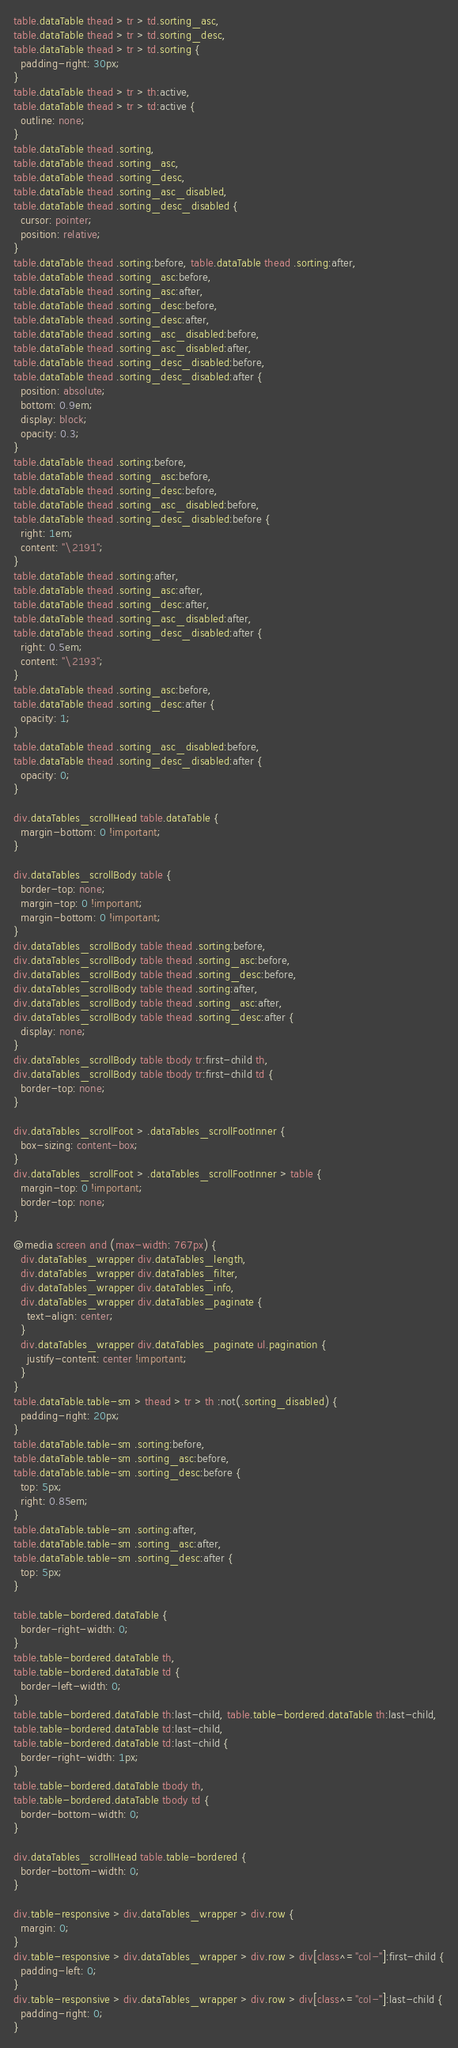Convert code to text. <code><loc_0><loc_0><loc_500><loc_500><_CSS_>table.dataTable thead > tr > td.sorting_asc,
table.dataTable thead > tr > td.sorting_desc,
table.dataTable thead > tr > td.sorting {
  padding-right: 30px;
}
table.dataTable thead > tr > th:active,
table.dataTable thead > tr > td:active {
  outline: none;
}
table.dataTable thead .sorting,
table.dataTable thead .sorting_asc,
table.dataTable thead .sorting_desc,
table.dataTable thead .sorting_asc_disabled,
table.dataTable thead .sorting_desc_disabled {
  cursor: pointer;
  position: relative;
}
table.dataTable thead .sorting:before, table.dataTable thead .sorting:after,
table.dataTable thead .sorting_asc:before,
table.dataTable thead .sorting_asc:after,
table.dataTable thead .sorting_desc:before,
table.dataTable thead .sorting_desc:after,
table.dataTable thead .sorting_asc_disabled:before,
table.dataTable thead .sorting_asc_disabled:after,
table.dataTable thead .sorting_desc_disabled:before,
table.dataTable thead .sorting_desc_disabled:after {
  position: absolute;
  bottom: 0.9em;
  display: block;
  opacity: 0.3;
}
table.dataTable thead .sorting:before,
table.dataTable thead .sorting_asc:before,
table.dataTable thead .sorting_desc:before,
table.dataTable thead .sorting_asc_disabled:before,
table.dataTable thead .sorting_desc_disabled:before {
  right: 1em;
  content: "\2191";
}
table.dataTable thead .sorting:after,
table.dataTable thead .sorting_asc:after,
table.dataTable thead .sorting_desc:after,
table.dataTable thead .sorting_asc_disabled:after,
table.dataTable thead .sorting_desc_disabled:after {
  right: 0.5em;
  content: "\2193";
}
table.dataTable thead .sorting_asc:before,
table.dataTable thead .sorting_desc:after {
  opacity: 1;
}
table.dataTable thead .sorting_asc_disabled:before,
table.dataTable thead .sorting_desc_disabled:after {
  opacity: 0;
}

div.dataTables_scrollHead table.dataTable {
  margin-bottom: 0 !important;
}

div.dataTables_scrollBody table {
  border-top: none;
  margin-top: 0 !important;
  margin-bottom: 0 !important;
}
div.dataTables_scrollBody table thead .sorting:before,
div.dataTables_scrollBody table thead .sorting_asc:before,
div.dataTables_scrollBody table thead .sorting_desc:before,
div.dataTables_scrollBody table thead .sorting:after,
div.dataTables_scrollBody table thead .sorting_asc:after,
div.dataTables_scrollBody table thead .sorting_desc:after {
  display: none;
}
div.dataTables_scrollBody table tbody tr:first-child th,
div.dataTables_scrollBody table tbody tr:first-child td {
  border-top: none;
}

div.dataTables_scrollFoot > .dataTables_scrollFootInner {
  box-sizing: content-box;
}
div.dataTables_scrollFoot > .dataTables_scrollFootInner > table {
  margin-top: 0 !important;
  border-top: none;
}

@media screen and (max-width: 767px) {
  div.dataTables_wrapper div.dataTables_length,
  div.dataTables_wrapper div.dataTables_filter,
  div.dataTables_wrapper div.dataTables_info,
  div.dataTables_wrapper div.dataTables_paginate {
    text-align: center;
  }
  div.dataTables_wrapper div.dataTables_paginate ul.pagination {
    justify-content: center !important;
  }
}
table.dataTable.table-sm > thead > tr > th :not(.sorting_disabled) {
  padding-right: 20px;
}
table.dataTable.table-sm .sorting:before,
table.dataTable.table-sm .sorting_asc:before,
table.dataTable.table-sm .sorting_desc:before {
  top: 5px;
  right: 0.85em;
}
table.dataTable.table-sm .sorting:after,
table.dataTable.table-sm .sorting_asc:after,
table.dataTable.table-sm .sorting_desc:after {
  top: 5px;
}

table.table-bordered.dataTable {
  border-right-width: 0;
}
table.table-bordered.dataTable th,
table.table-bordered.dataTable td {
  border-left-width: 0;
}
table.table-bordered.dataTable th:last-child, table.table-bordered.dataTable th:last-child,
table.table-bordered.dataTable td:last-child,
table.table-bordered.dataTable td:last-child {
  border-right-width: 1px;
}
table.table-bordered.dataTable tbody th,
table.table-bordered.dataTable tbody td {
  border-bottom-width: 0;
}

div.dataTables_scrollHead table.table-bordered {
  border-bottom-width: 0;
}

div.table-responsive > div.dataTables_wrapper > div.row {
  margin: 0;
}
div.table-responsive > div.dataTables_wrapper > div.row > div[class^="col-"]:first-child {
  padding-left: 0;
}
div.table-responsive > div.dataTables_wrapper > div.row > div[class^="col-"]:last-child {
  padding-right: 0;
}
</code> 